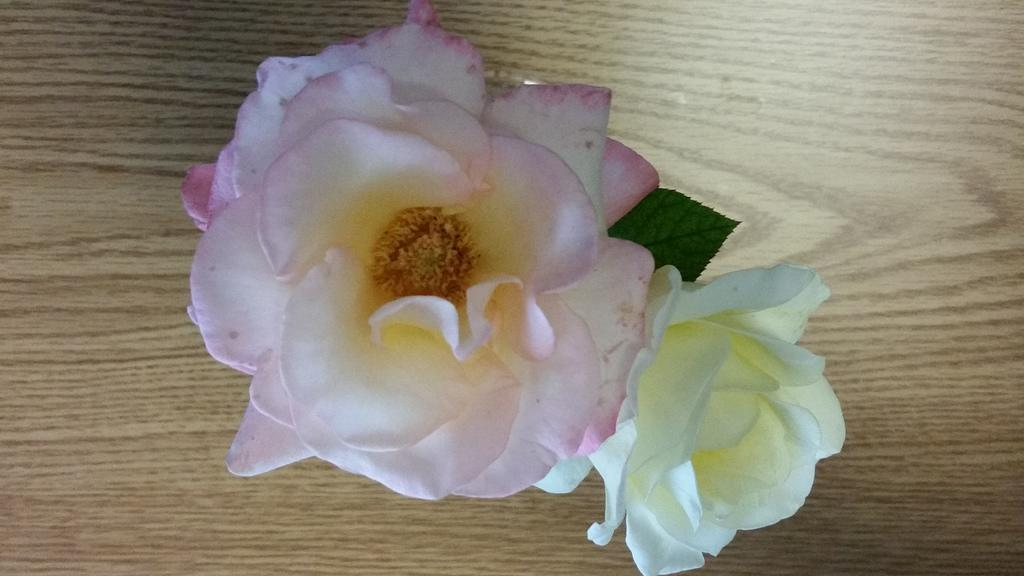What type of flowers are in the image? There are rose flowers in the image. What colors are the rose flowers? The rose flowers are pink and white in color. Where are the flowers placed in the image? The flowers are kept on a wooden table. How many buns are placed next to the flowers on the wooden table? There are no buns present in the image; it only features rose flowers on a wooden table. 